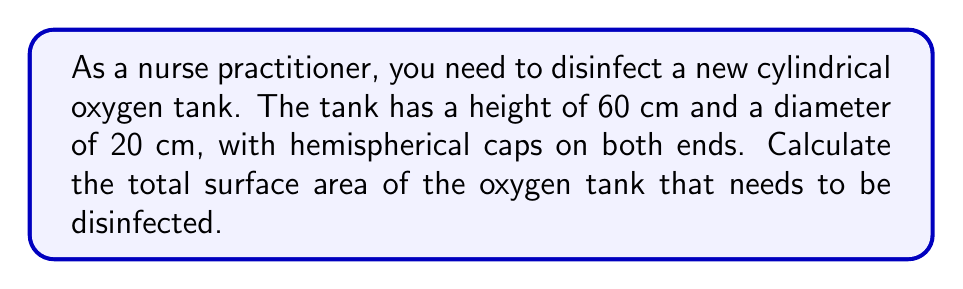Can you solve this math problem? Let's break this down step-by-step:

1) The tank consists of three parts: a cylindrical body and two hemispherical caps.

2) For the cylindrical body:
   - Surface area = $\pi d h$, where $d$ is diameter and $h$ is height
   - $SA_{cylinder} = \pi \cdot 20 \cdot 60 = 1200\pi$ cm²

3) For each hemispherical cap:
   - Surface area = $2\pi r^2$, where $r$ is radius (half the diameter)
   - $SA_{hemisphere} = 2\pi \cdot (10)^2 = 200\pi$ cm²

4) We have two hemispherical caps, so:
   - Total $SA_{caps} = 2 \cdot 200\pi = 400\pi$ cm²

5) Total surface area:
   $SA_{total} = SA_{cylinder} + SA_{caps}$
   $SA_{total} = 1200\pi + 400\pi = 1600\pi$ cm²

6) To get the final answer in cm², multiply by $\pi$:
   $SA_{total} = 1600\pi \approx 5026.55$ cm²

[asy]
import geometry;

size(200);
draw(circle((0,0),20));
draw((0,-20)--(0,60));
draw((20,-20)--(20,60));
draw(arc((0,60),20,0,180));
draw(arc((0,-20),20,180,360));
label("60 cm", (22,20), E);
label("20 cm", (0,-22), S);
[/asy]
Answer: 5026.55 cm² 